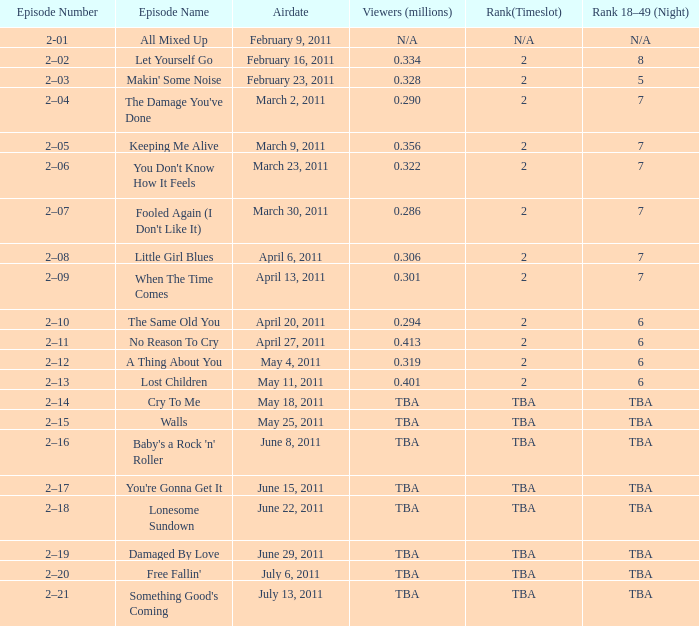What is the total rank on airdate march 30, 2011? 1.0. 